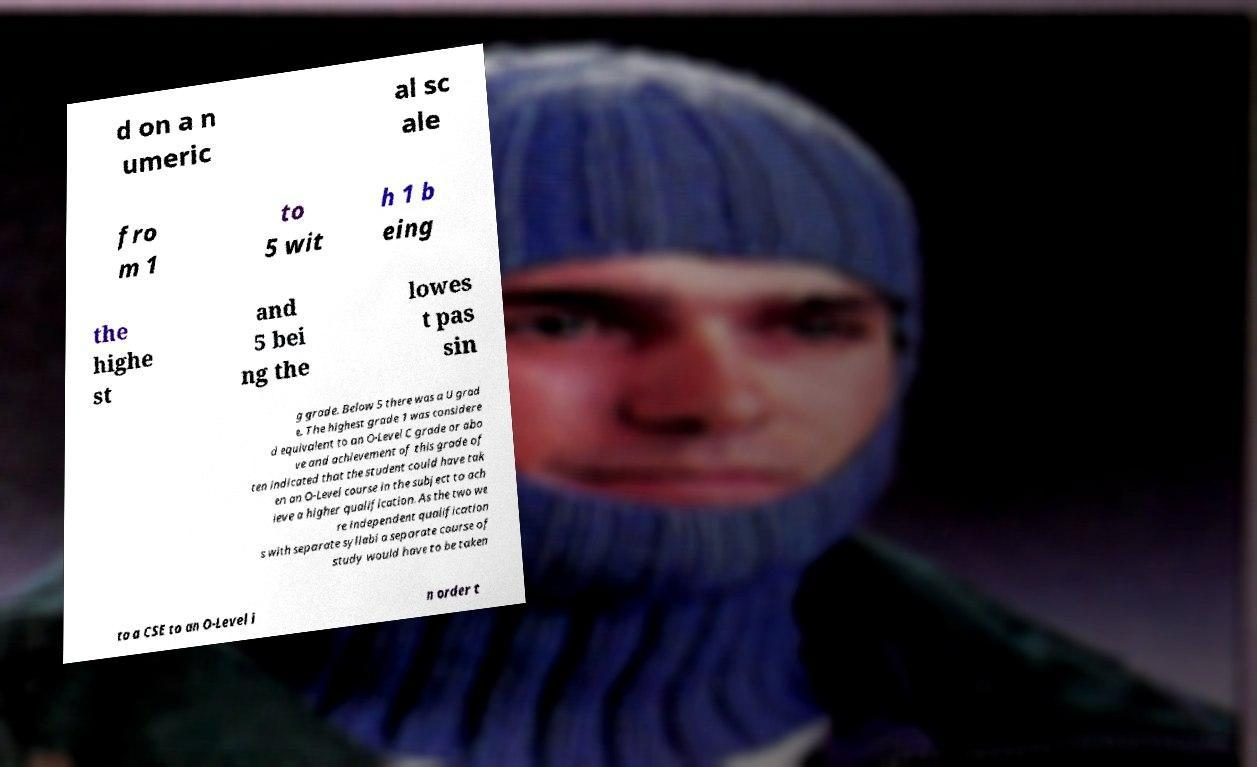There's text embedded in this image that I need extracted. Can you transcribe it verbatim? d on a n umeric al sc ale fro m 1 to 5 wit h 1 b eing the highe st and 5 bei ng the lowes t pas sin g grade. Below 5 there was a U grad e. The highest grade 1 was considere d equivalent to an O-Level C grade or abo ve and achievement of this grade of ten indicated that the student could have tak en an O-Level course in the subject to ach ieve a higher qualification. As the two we re independent qualification s with separate syllabi a separate course of study would have to be taken to a CSE to an O-Level i n order t 